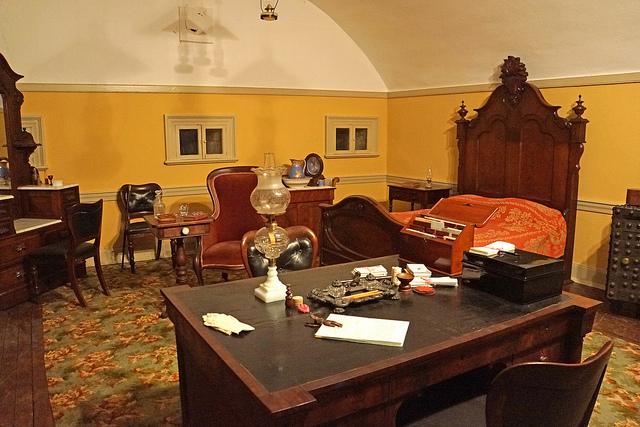Is the furniture in this room antique?
Answer briefly. Yes. Is this office kept neat?
Be succinct. Yes. What kind of room is this?
Write a very short answer. Bedroom. 